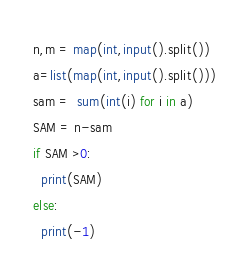Convert code to text. <code><loc_0><loc_0><loc_500><loc_500><_Python_>n,m = map(int,input().split())
a=list(map(int,input().split()))
sam =  sum(int(i) for i in a)
SAM = n-sam
if SAM >0:
  print(SAM)
else:
  print(-1)</code> 